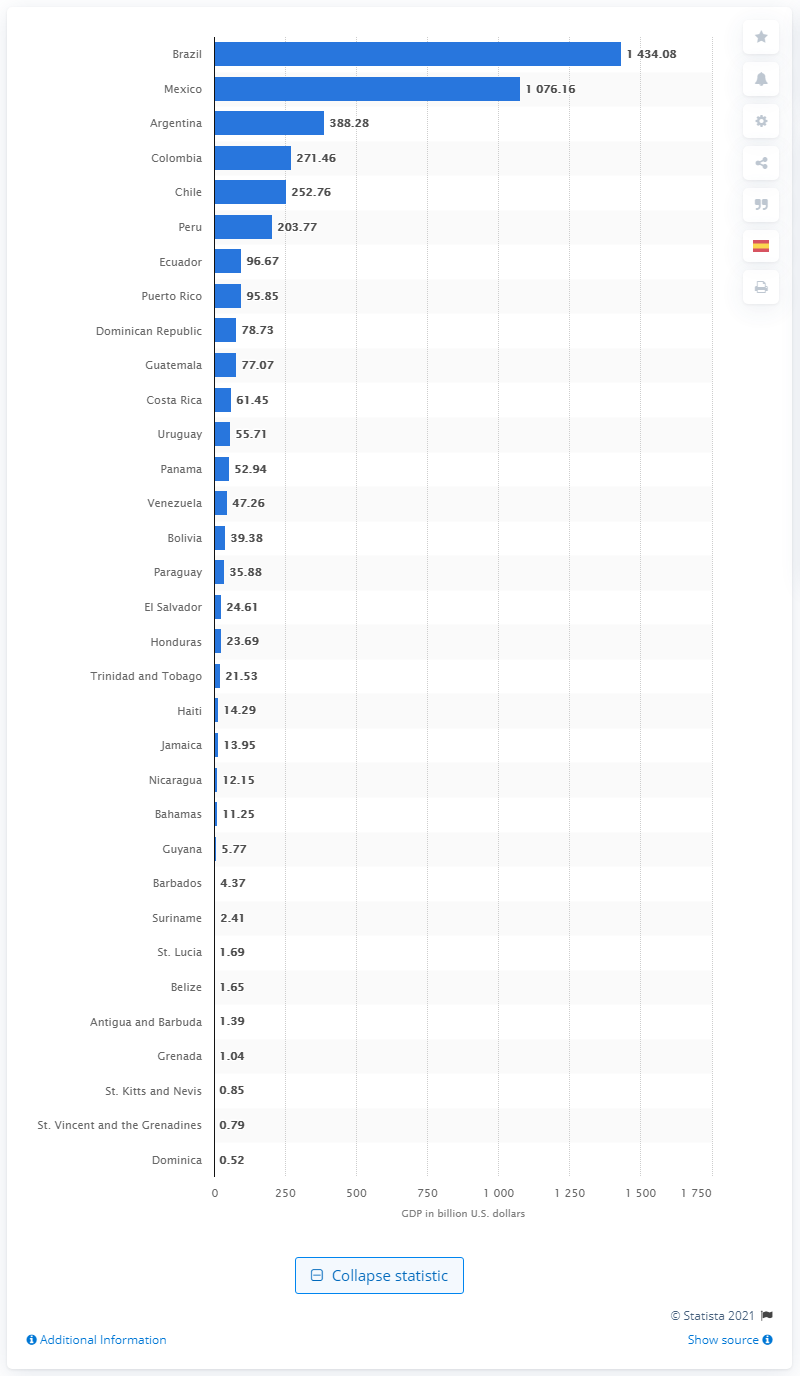List a handful of essential elements in this visual. In 2020, the Gross Domestic Product (GDP) of Brazil was 1434.08 billion dollars. 